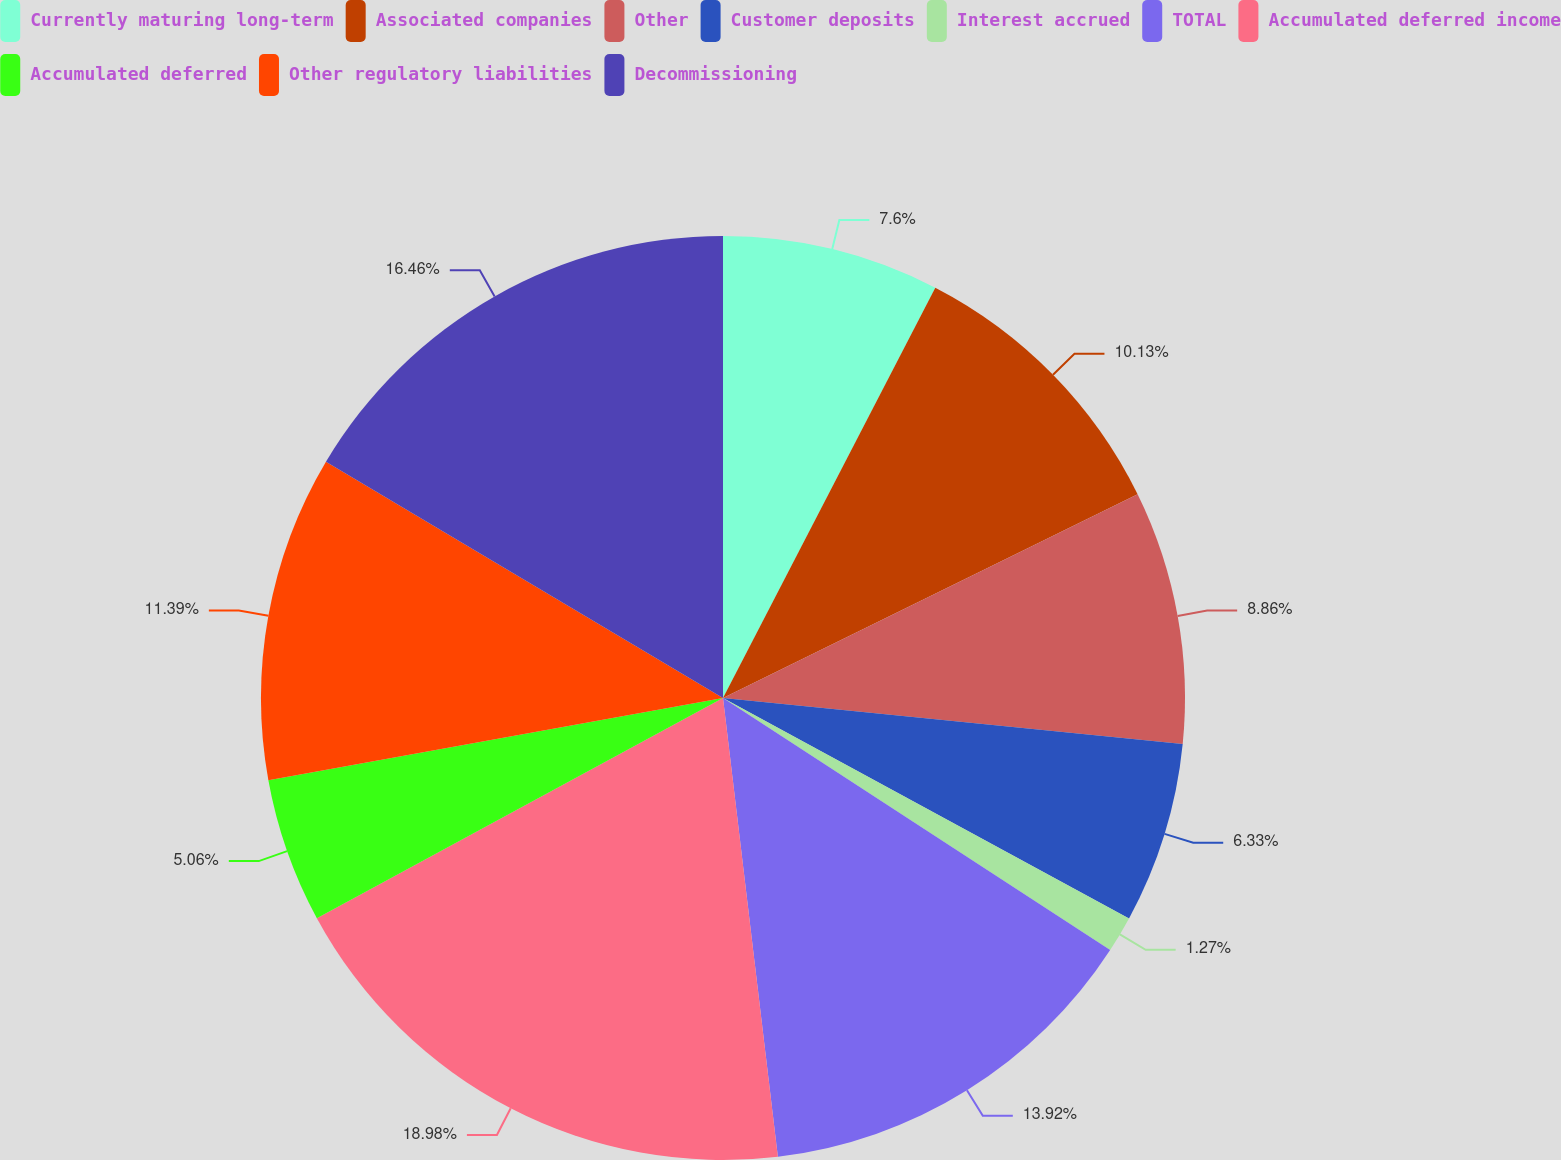Convert chart. <chart><loc_0><loc_0><loc_500><loc_500><pie_chart><fcel>Currently maturing long-term<fcel>Associated companies<fcel>Other<fcel>Customer deposits<fcel>Interest accrued<fcel>TOTAL<fcel>Accumulated deferred income<fcel>Accumulated deferred<fcel>Other regulatory liabilities<fcel>Decommissioning<nl><fcel>7.6%<fcel>10.13%<fcel>8.86%<fcel>6.33%<fcel>1.27%<fcel>13.92%<fcel>18.99%<fcel>5.06%<fcel>11.39%<fcel>16.46%<nl></chart> 